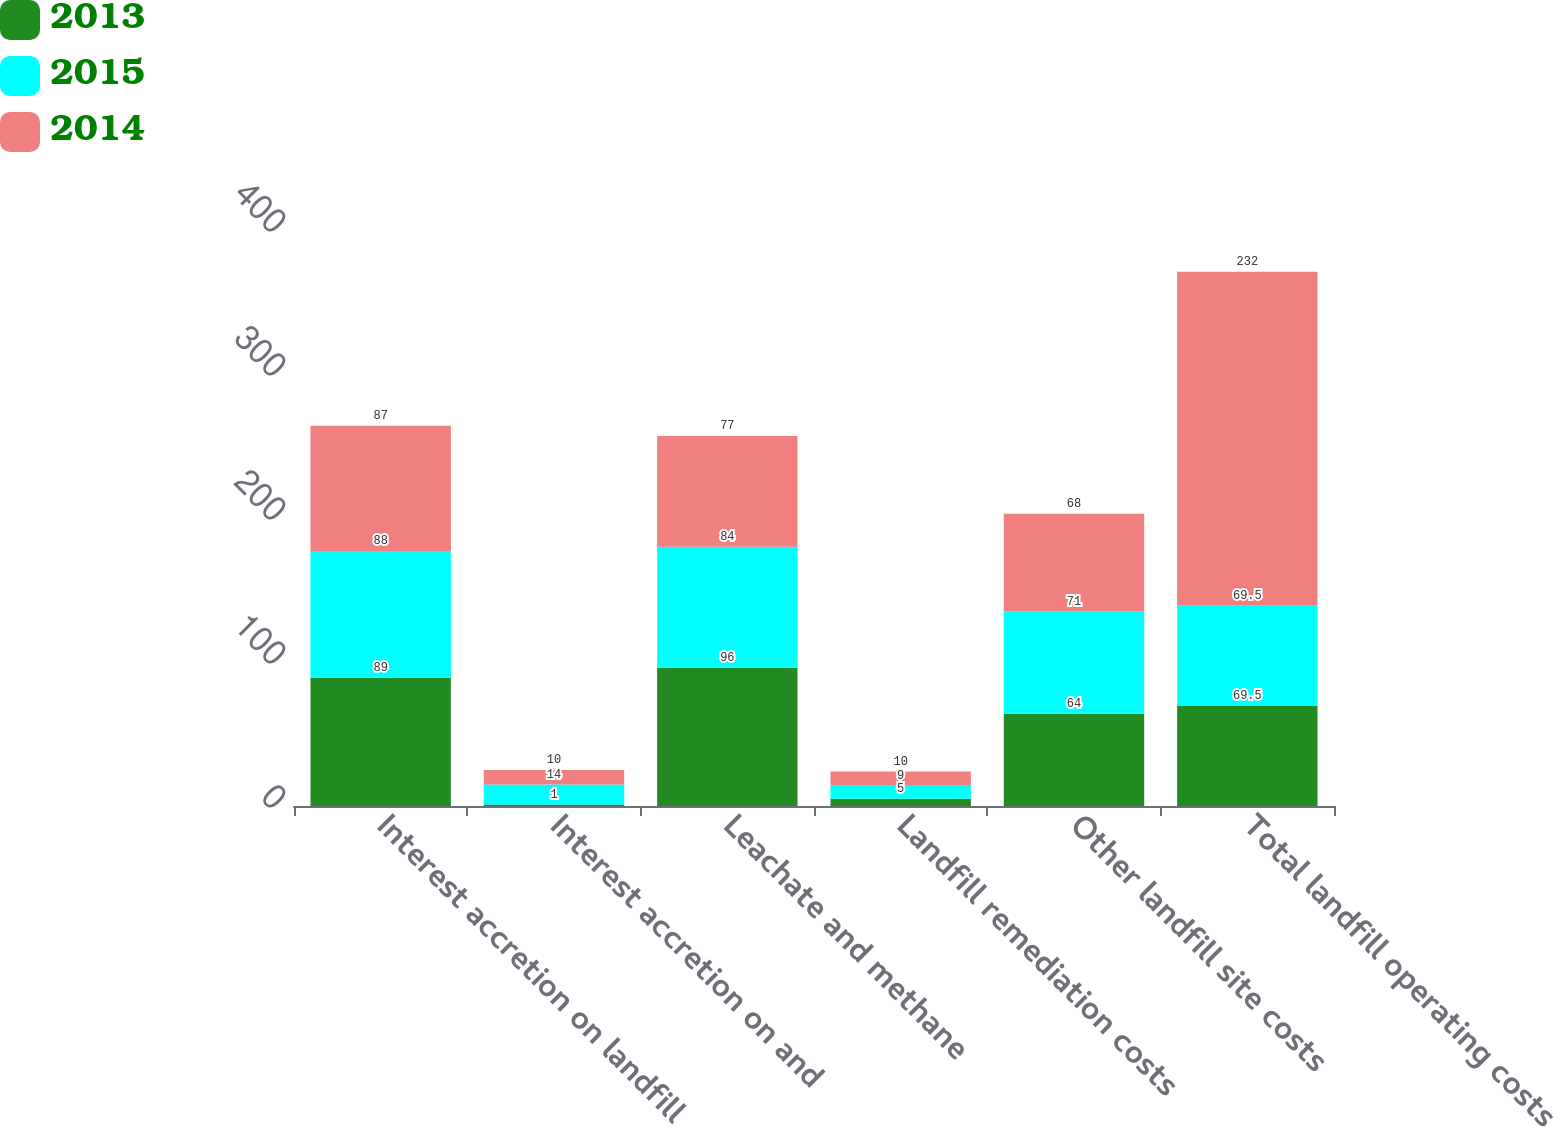<chart> <loc_0><loc_0><loc_500><loc_500><stacked_bar_chart><ecel><fcel>Interest accretion on landfill<fcel>Interest accretion on and<fcel>Leachate and methane<fcel>Landfill remediation costs<fcel>Other landfill site costs<fcel>Total landfill operating costs<nl><fcel>2013<fcel>89<fcel>1<fcel>96<fcel>5<fcel>64<fcel>69.5<nl><fcel>2015<fcel>88<fcel>14<fcel>84<fcel>9<fcel>71<fcel>69.5<nl><fcel>2014<fcel>87<fcel>10<fcel>77<fcel>10<fcel>68<fcel>232<nl></chart> 